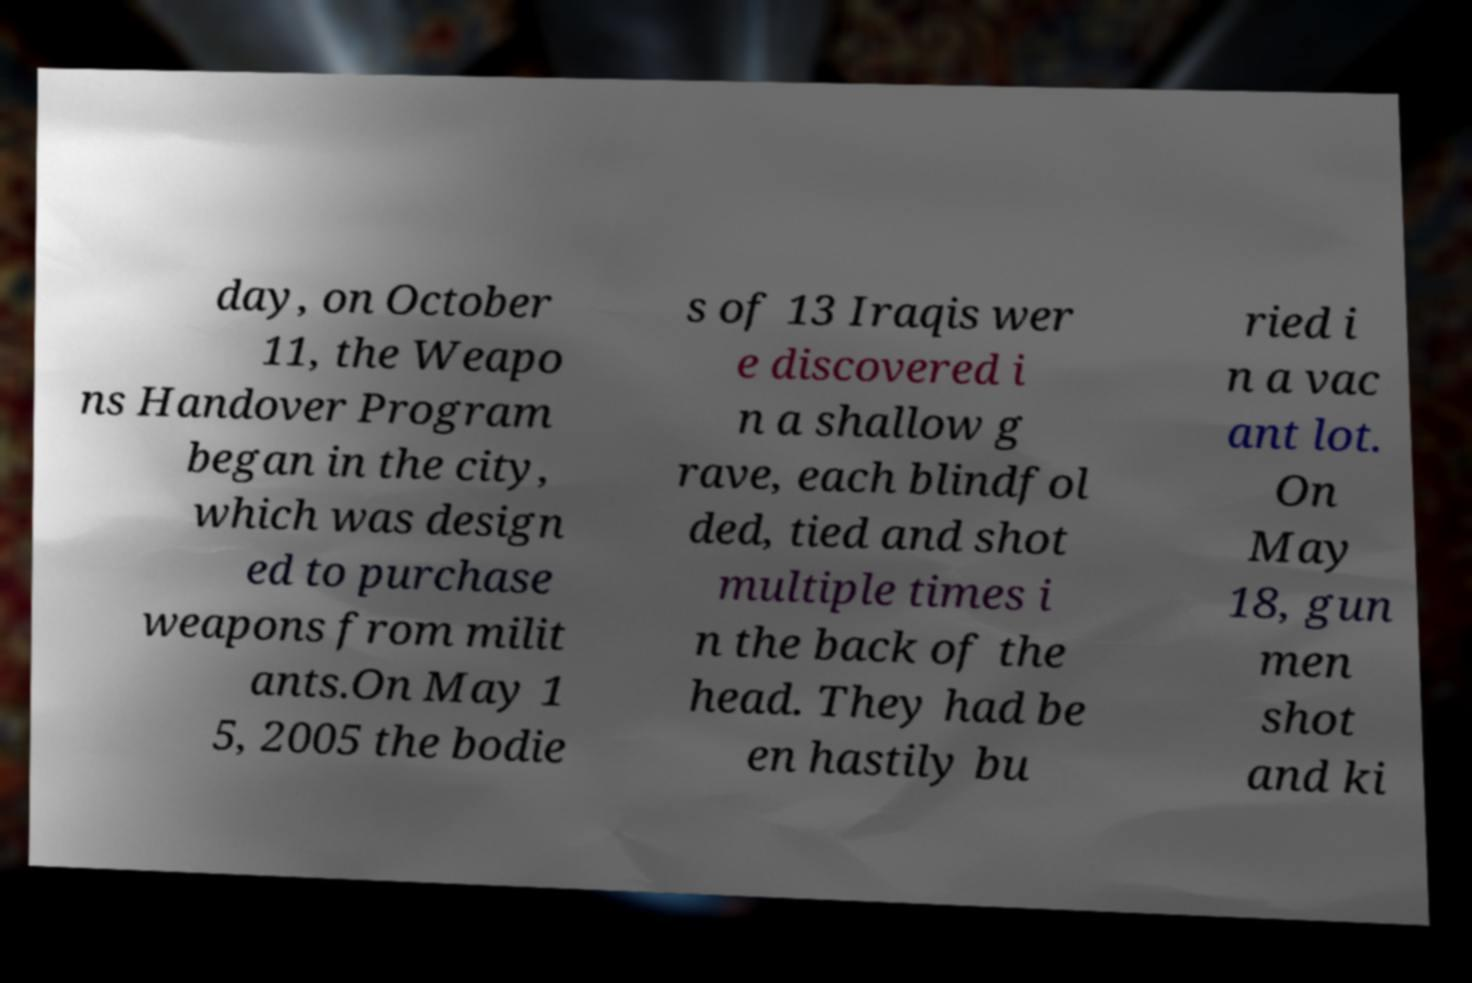For documentation purposes, I need the text within this image transcribed. Could you provide that? day, on October 11, the Weapo ns Handover Program began in the city, which was design ed to purchase weapons from milit ants.On May 1 5, 2005 the bodie s of 13 Iraqis wer e discovered i n a shallow g rave, each blindfol ded, tied and shot multiple times i n the back of the head. They had be en hastily bu ried i n a vac ant lot. On May 18, gun men shot and ki 